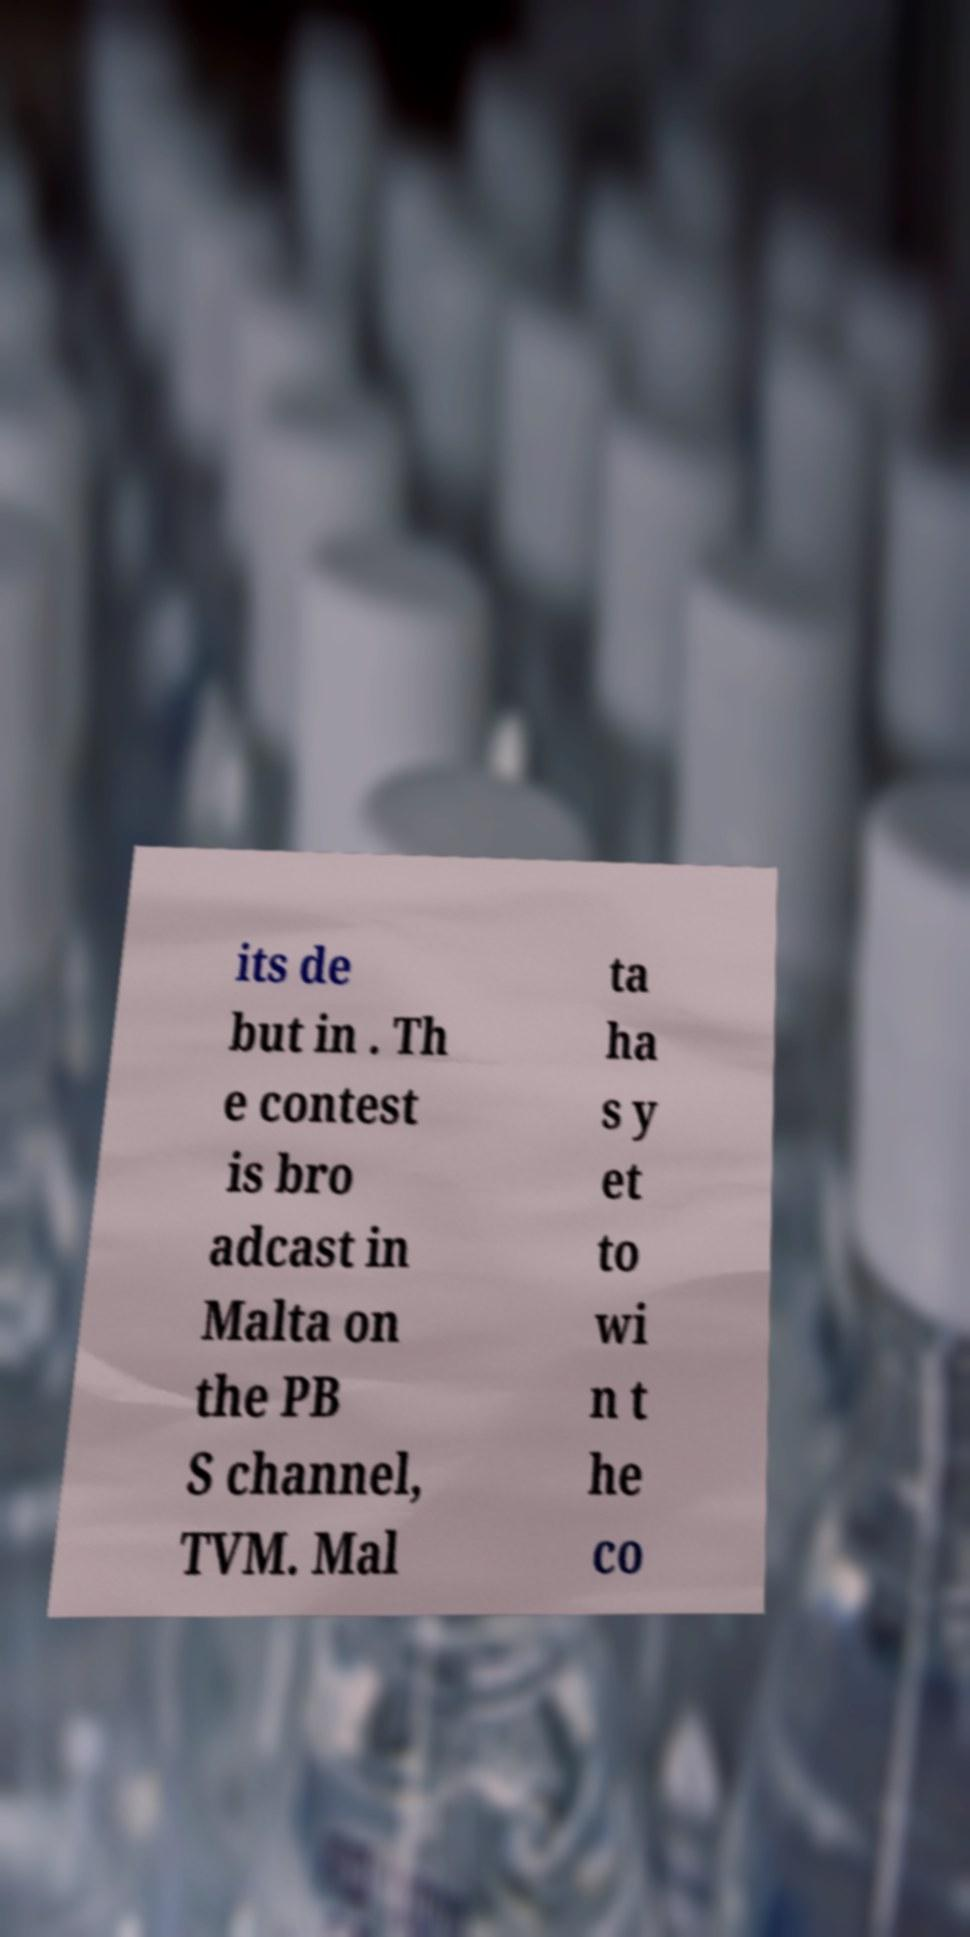Please identify and transcribe the text found in this image. its de but in . Th e contest is bro adcast in Malta on the PB S channel, TVM. Mal ta ha s y et to wi n t he co 